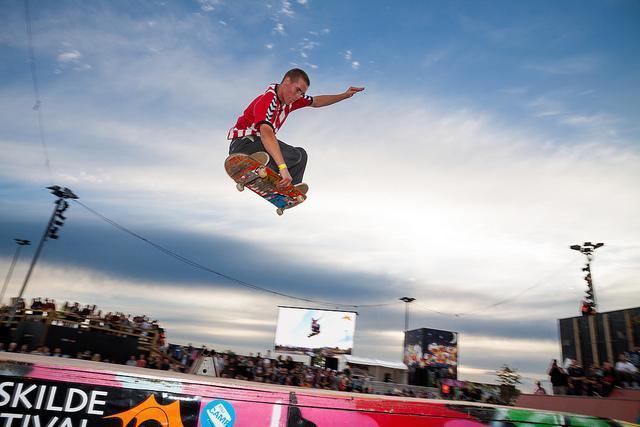How many lights are on top of each pole?
Give a very brief answer. 4. How many people can you see?
Give a very brief answer. 2. 